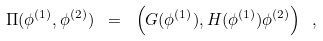Convert formula to latex. <formula><loc_0><loc_0><loc_500><loc_500>\Pi ( \phi ^ { ( 1 ) } , \phi ^ { ( 2 ) } ) \ = \ \left ( G ( \phi ^ { ( 1 ) } ) , H ( \phi ^ { ( 1 ) } ) \phi ^ { ( 2 ) } \right ) \ ,</formula> 